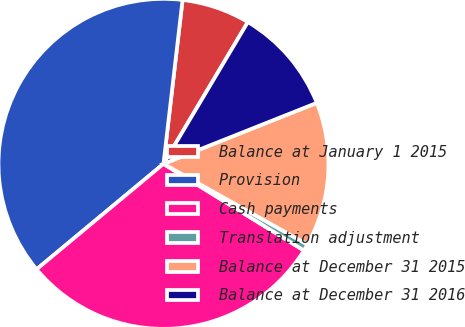Convert chart to OTSL. <chart><loc_0><loc_0><loc_500><loc_500><pie_chart><fcel>Balance at January 1 2015<fcel>Provision<fcel>Cash payments<fcel>Translation adjustment<fcel>Balance at December 31 2015<fcel>Balance at December 31 2016<nl><fcel>6.7%<fcel>37.88%<fcel>30.17%<fcel>0.67%<fcel>14.15%<fcel>10.43%<nl></chart> 